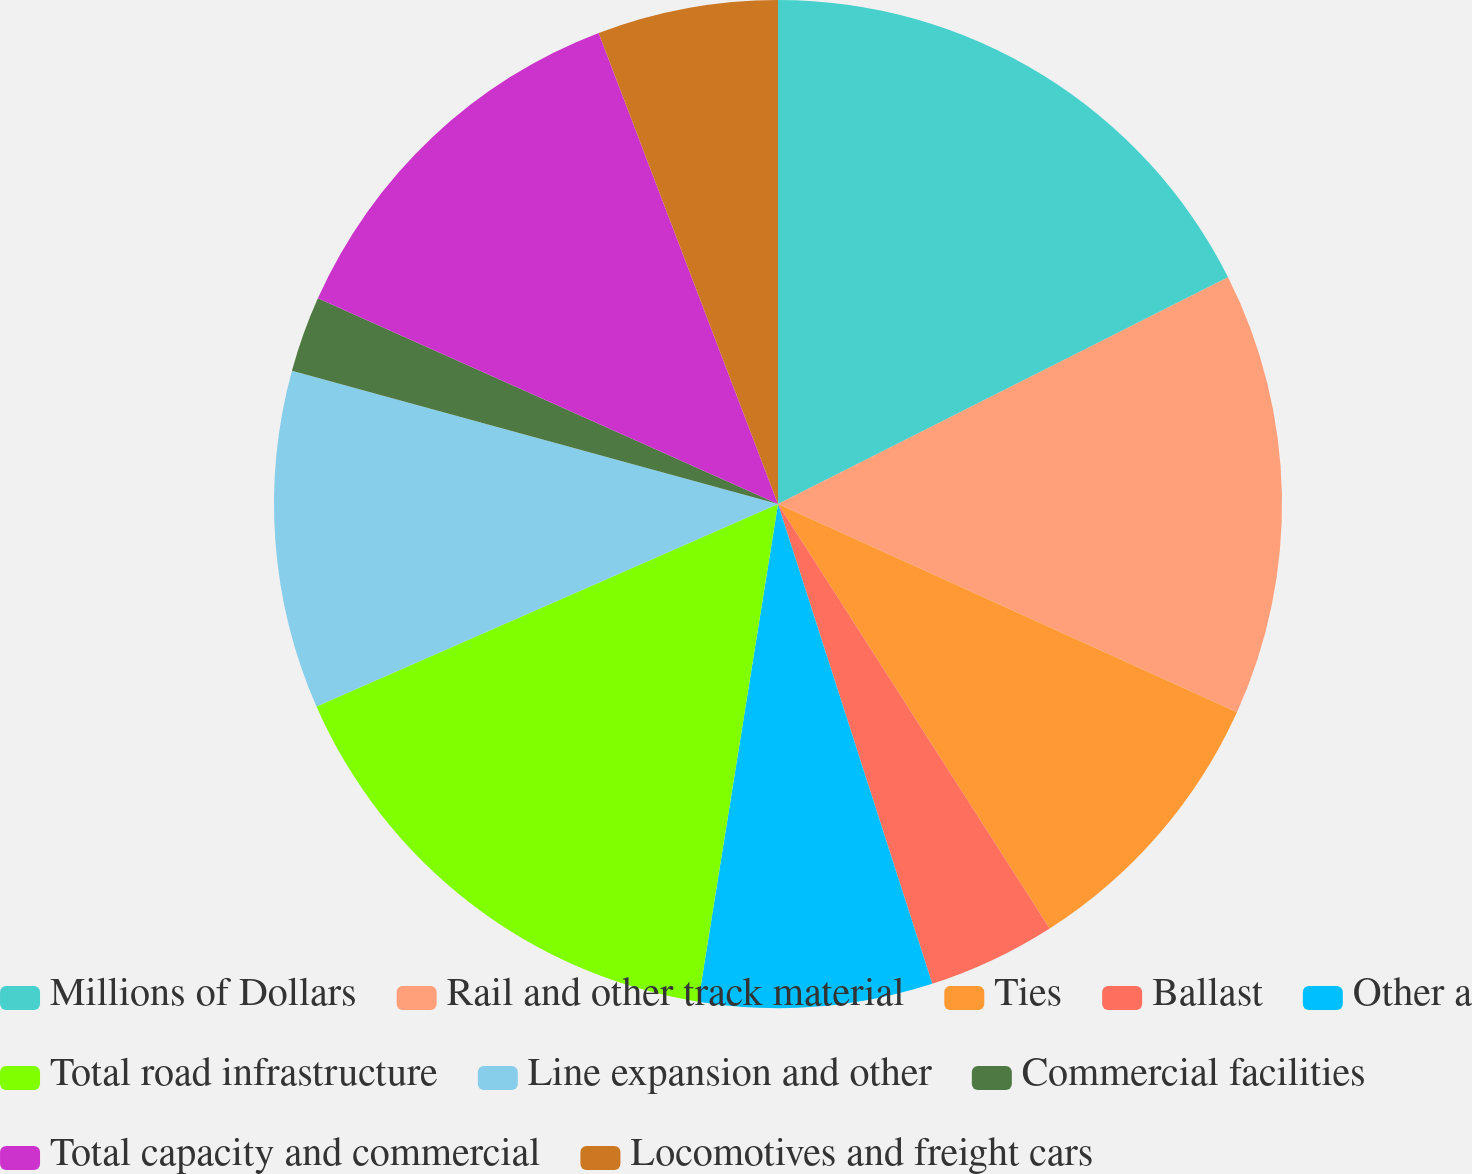Convert chart. <chart><loc_0><loc_0><loc_500><loc_500><pie_chart><fcel>Millions of Dollars<fcel>Rail and other track material<fcel>Ties<fcel>Ballast<fcel>Other a<fcel>Total road infrastructure<fcel>Line expansion and other<fcel>Commercial facilities<fcel>Total capacity and commercial<fcel>Locomotives and freight cars<nl><fcel>17.57%<fcel>14.21%<fcel>9.16%<fcel>4.11%<fcel>7.48%<fcel>15.89%<fcel>10.84%<fcel>2.43%<fcel>12.52%<fcel>5.79%<nl></chart> 